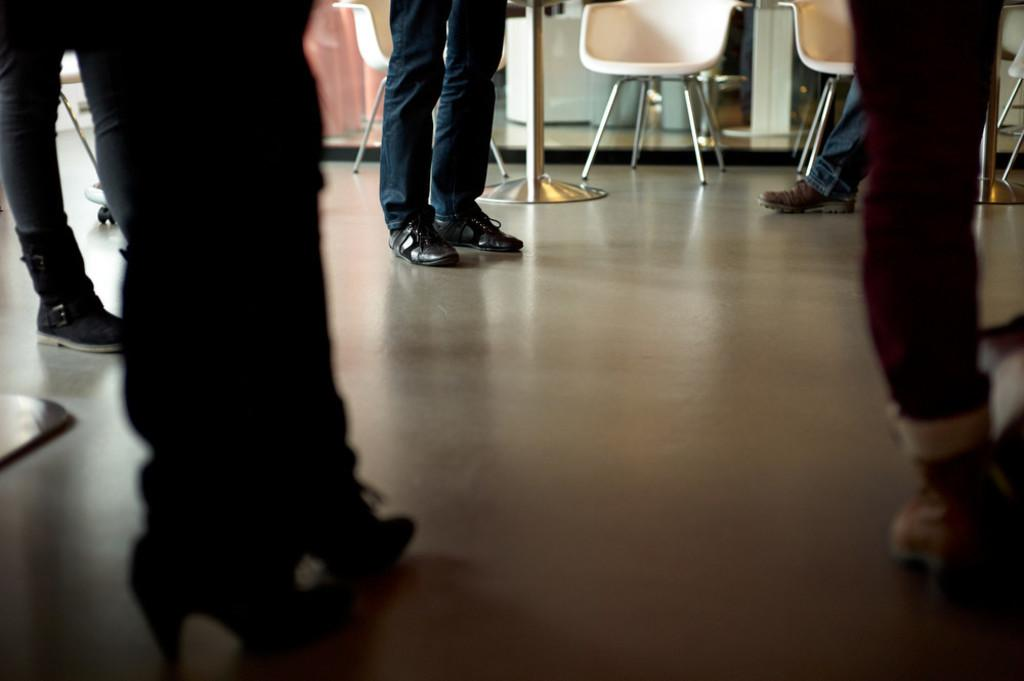What can be seen in the image? There are people standing in the image. Where are the people standing? The people are standing on the floor. What else is visible in the image besides the people? There are chairs visible in the image. Where are the chairs located in relation to the people? The chairs are at the back. Can you see the grandmother sitting in the quiver in the image? There is no grandmother or quiver present in the image. 